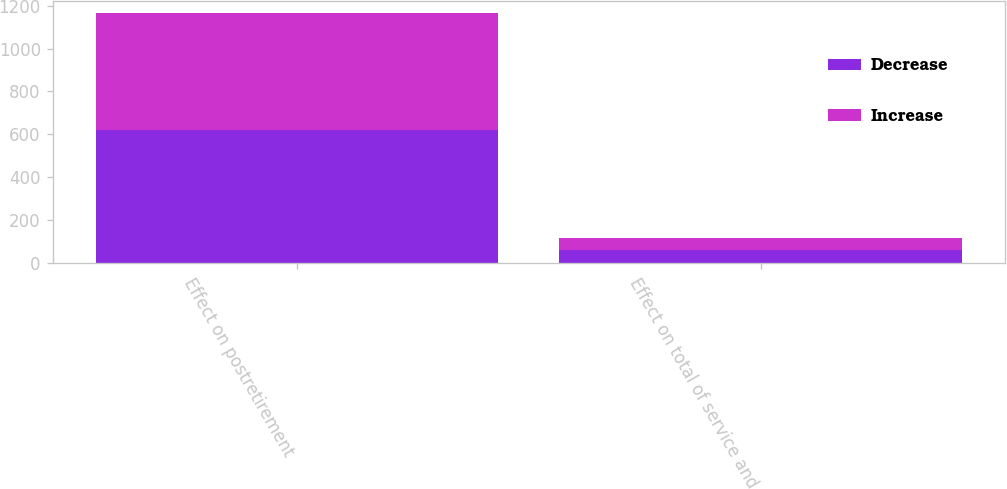Convert chart. <chart><loc_0><loc_0><loc_500><loc_500><stacked_bar_chart><ecel><fcel>Effect on postretirement<fcel>Effect on total of service and<nl><fcel>Decrease<fcel>621<fcel>59<nl><fcel>Increase<fcel>545<fcel>55<nl></chart> 